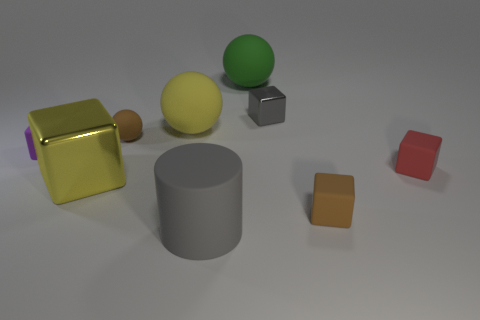How many other balls have the same color as the tiny ball?
Provide a short and direct response. 0. Are there any other things that are the same shape as the large gray thing?
Your response must be concise. No. How many other things are the same size as the purple matte block?
Your answer should be very brief. 4. There is a shiny thing that is on the left side of the big green object; what size is it?
Your answer should be compact. Large. What is the material of the brown thing that is in front of the tiny block left of the big yellow thing that is left of the large yellow matte sphere?
Provide a short and direct response. Rubber. Is the red object the same shape as the green matte thing?
Provide a succinct answer. No. What number of metallic things are large red cylinders or large spheres?
Make the answer very short. 0. What number of large gray blocks are there?
Your answer should be compact. 0. There is a sphere that is the same size as the gray cube; what color is it?
Your answer should be very brief. Brown. Does the yellow sphere have the same size as the cylinder?
Provide a succinct answer. Yes. 